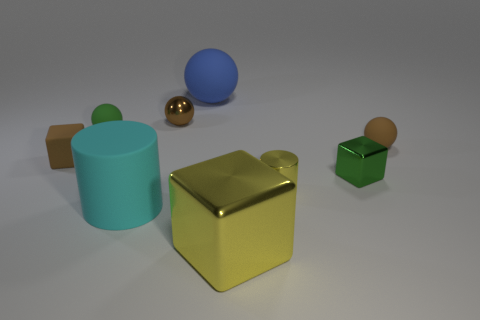The cyan object that is the same shape as the small yellow thing is what size?
Offer a very short reply. Large. What size is the green cube behind the small metal cylinder?
Offer a very short reply. Small. Is the tiny cylinder the same color as the big shiny object?
Your answer should be compact. Yes. Are there any other things that are the same shape as the small green shiny object?
Your response must be concise. Yes. What material is the ball that is the same color as the tiny metal cube?
Provide a succinct answer. Rubber. Are there the same number of big cubes left of the big cyan matte cylinder and green shiny blocks?
Your answer should be very brief. No. There is a tiny green metallic object; are there any brown metal balls on the right side of it?
Your answer should be very brief. No. Is the shape of the green metal object the same as the small green thing on the left side of the tiny yellow thing?
Offer a terse response. No. There is a tiny ball that is made of the same material as the tiny cylinder; what is its color?
Give a very brief answer. Brown. What is the color of the shiny cylinder?
Provide a succinct answer. Yellow. 